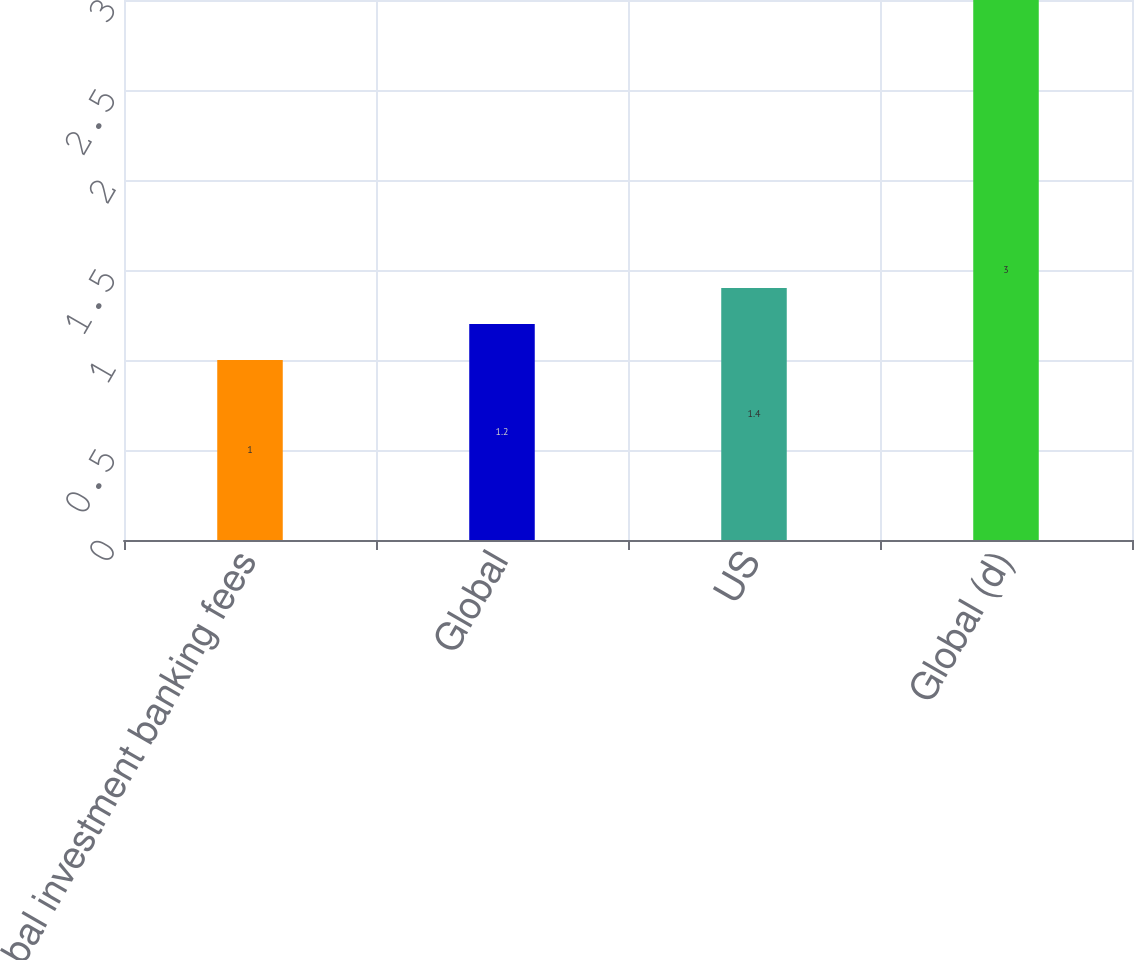<chart> <loc_0><loc_0><loc_500><loc_500><bar_chart><fcel>Global investment banking fees<fcel>Global<fcel>US<fcel>Global (d)<nl><fcel>1<fcel>1.2<fcel>1.4<fcel>3<nl></chart> 